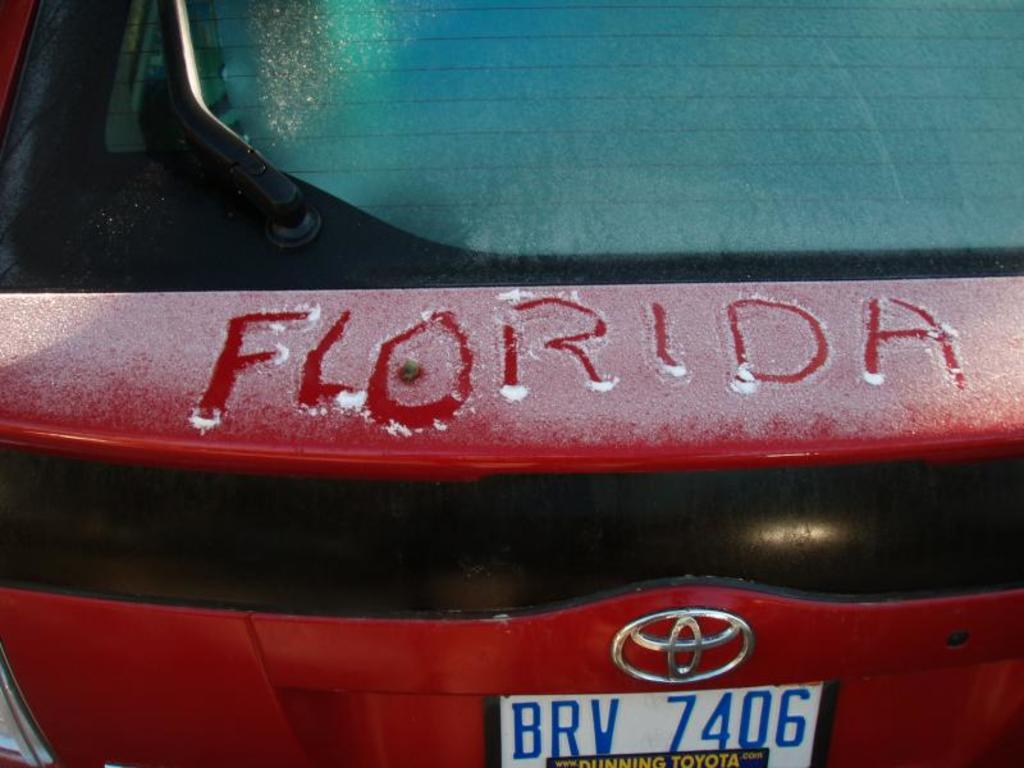<image>
Render a clear and concise summary of the photo. Florida is traced in the snow that is on a red car. 